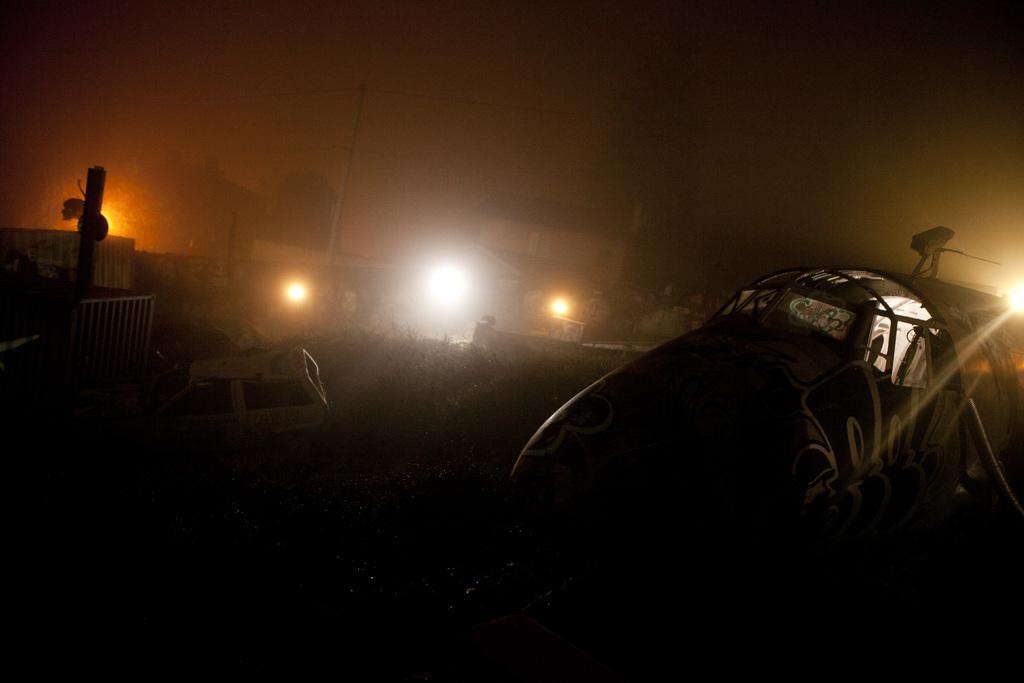What types of objects can be seen in the image? There are vehicles, plants, a house, pillars, lights, and a wall in the image. Can you describe the house in the image? The house has pillars and a wall. What might be used for illumination in the image? There are lights in the image that can be used for illumination. Are there any natural elements present in the image? Yes, there are plants in the image. What type of locket is hanging from the wall in the image? There is no locket present in the image; it features vehicles, plants, a house, pillars, lights, and a wall. What kind of leather material can be seen on the vehicles in the image? There is no leather material mentioned or visible on the vehicles in the image. 